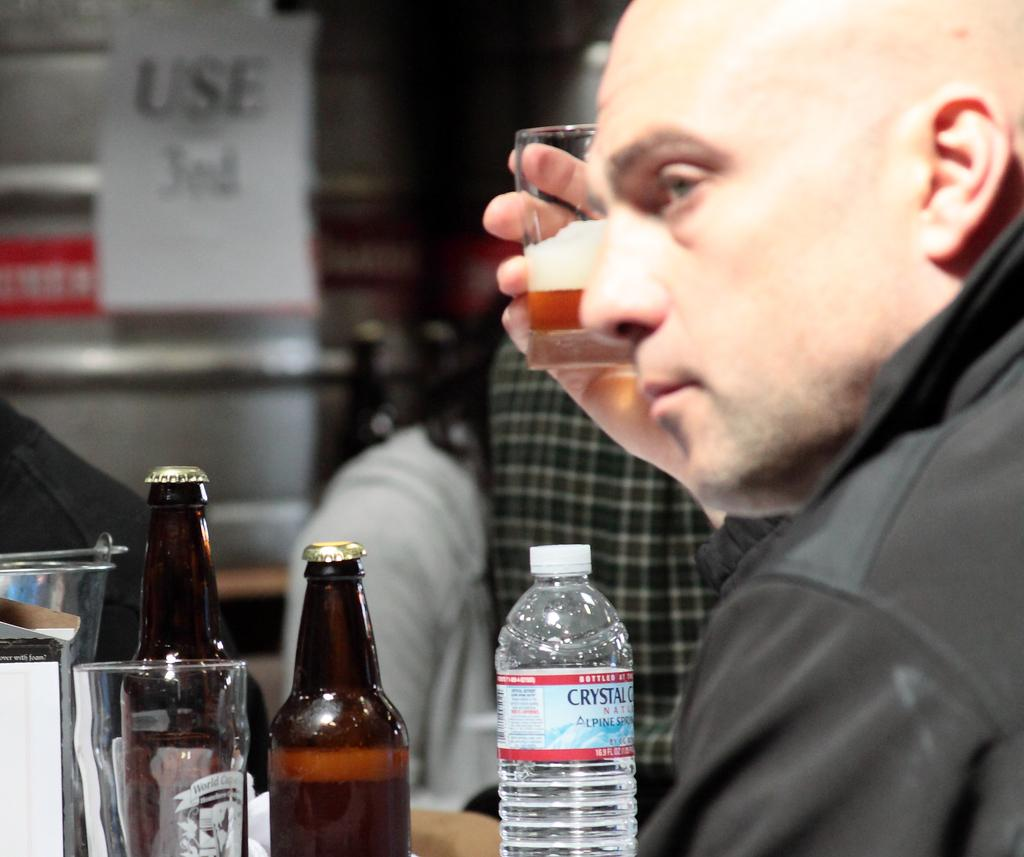<image>
Relay a brief, clear account of the picture shown. A bottle of Crystal Geyser water sits on fromt of a man on a table with beer bottles. 